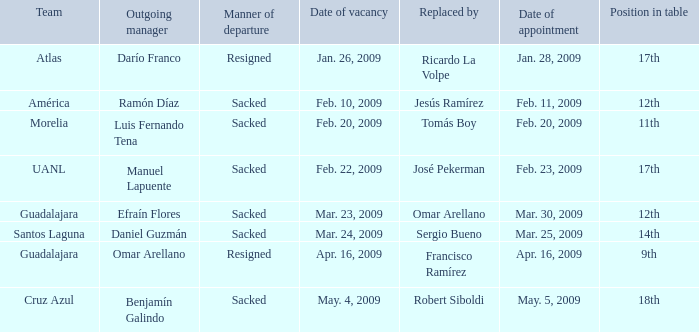What is Position in Table, when Team is "Morelia"? 11th. 